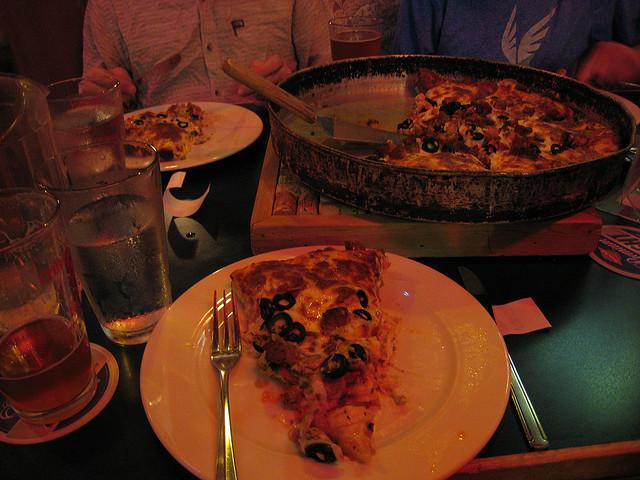What is on the pizza?

Choices:
A) red peppers
B) sausages
C) olives
D) banana olives 